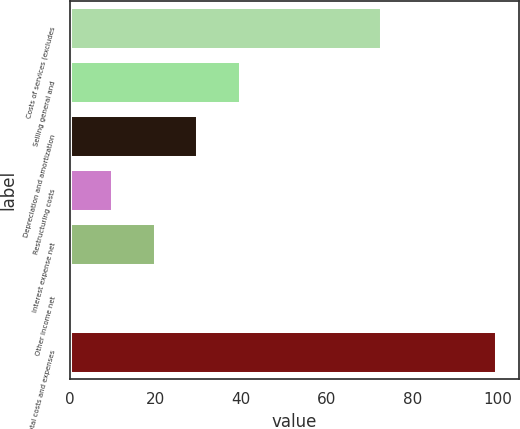Convert chart. <chart><loc_0><loc_0><loc_500><loc_500><bar_chart><fcel>Costs of services (excludes<fcel>Selling general and<fcel>Depreciation and amortization<fcel>Restructuring costs<fcel>Interest expense net<fcel>Other income net<fcel>Total costs and expenses<nl><fcel>73<fcel>40.02<fcel>30.04<fcel>10.08<fcel>20.06<fcel>0.1<fcel>99.9<nl></chart> 